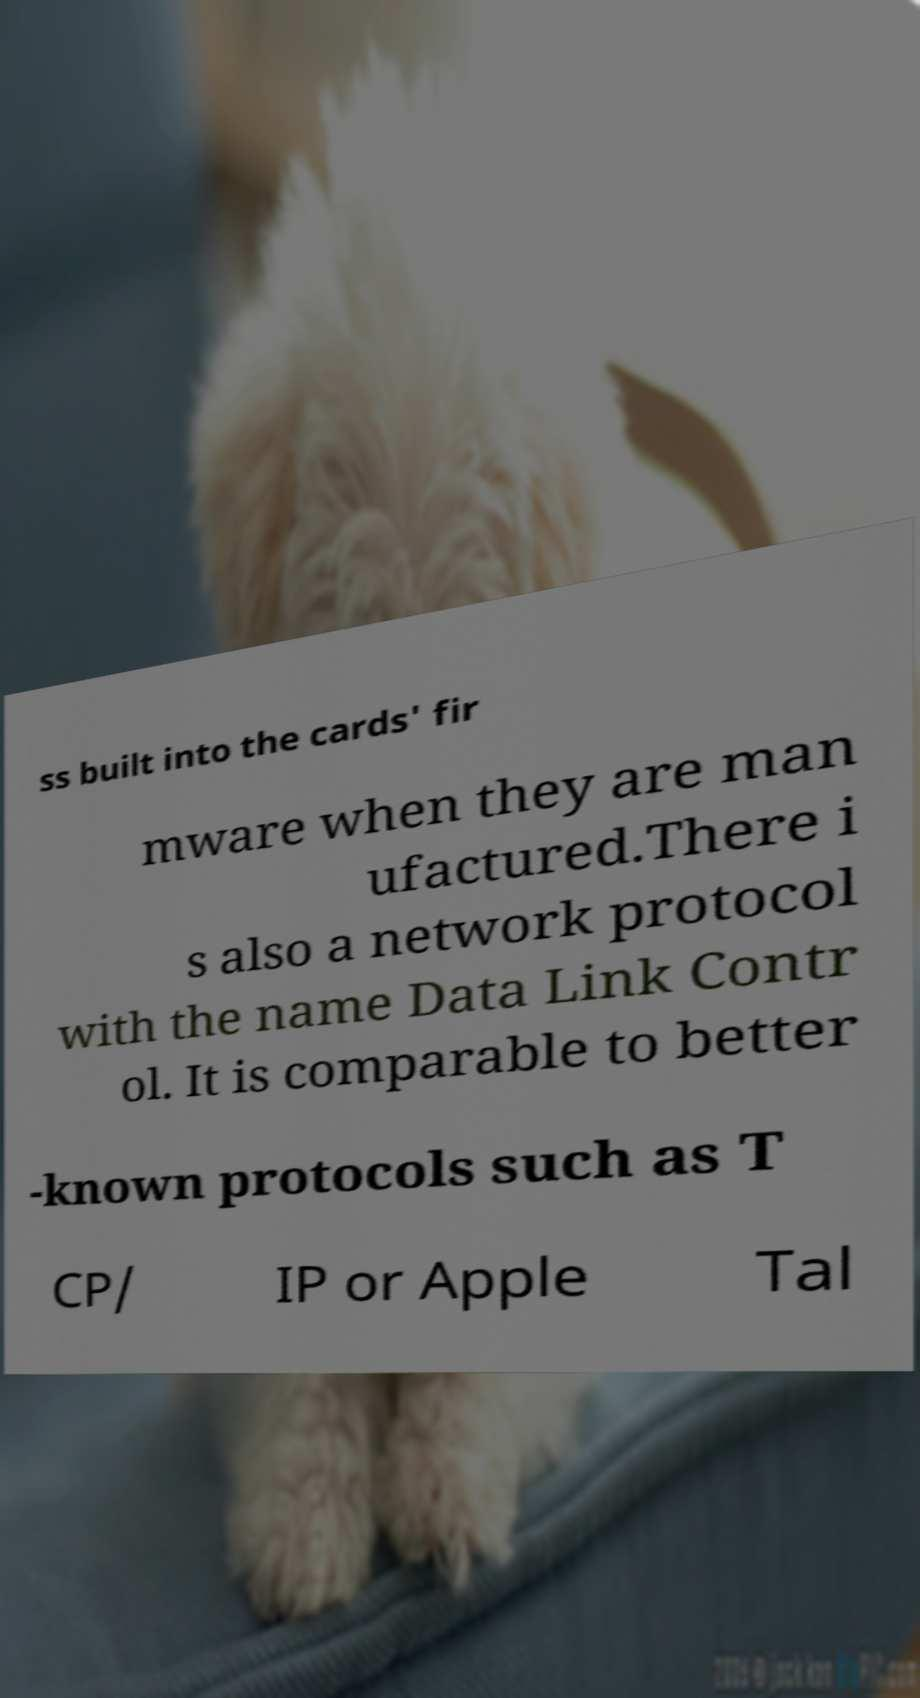Can you accurately transcribe the text from the provided image for me? ss built into the cards' fir mware when they are man ufactured.There i s also a network protocol with the name Data Link Contr ol. It is comparable to better -known protocols such as T CP/ IP or Apple Tal 